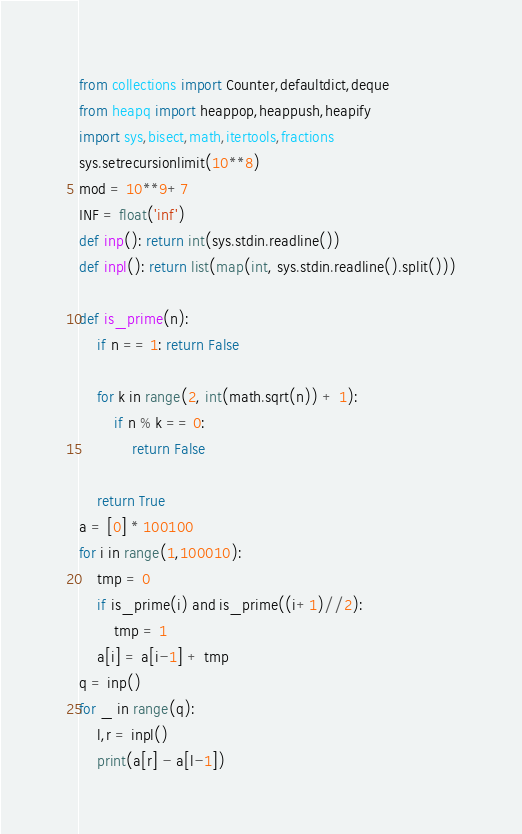<code> <loc_0><loc_0><loc_500><loc_500><_Python_>from collections import Counter,defaultdict,deque
from heapq import heappop,heappush,heapify
import sys,bisect,math,itertools,fractions
sys.setrecursionlimit(10**8)
mod = 10**9+7
INF = float('inf')
def inp(): return int(sys.stdin.readline())
def inpl(): return list(map(int, sys.stdin.readline().split()))

def is_prime(n):
    if n == 1: return False

    for k in range(2, int(math.sqrt(n)) + 1):
        if n % k == 0:
            return False

    return True
a = [0] * 100100
for i in range(1,100010):
    tmp = 0
    if is_prime(i) and is_prime((i+1)//2):
        tmp = 1
    a[i] = a[i-1] + tmp
q = inp()
for _ in range(q):
    l,r = inpl()
    print(a[r] - a[l-1])</code> 